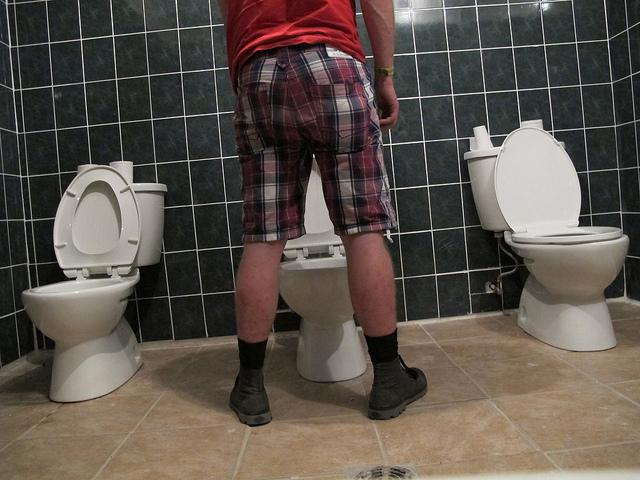Which room is this? Please explain your reasoning. men's restroom. A man is standing in from of a urinal that is in a row of urinals and he is standing like he is using the bathroom 